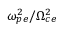Convert formula to latex. <formula><loc_0><loc_0><loc_500><loc_500>\omega _ { p e } ^ { 2 } / \Omega _ { c e } ^ { 2 }</formula> 